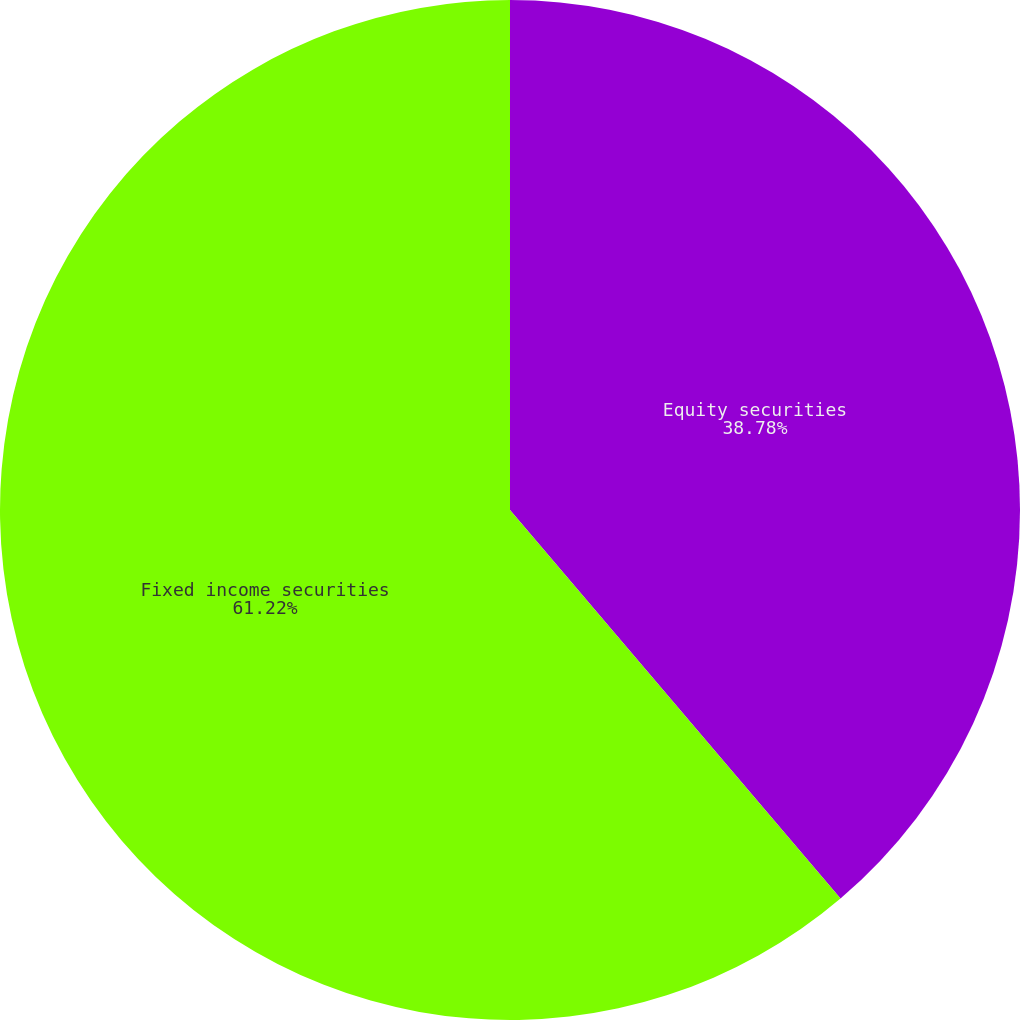<chart> <loc_0><loc_0><loc_500><loc_500><pie_chart><fcel>Equity securities<fcel>Fixed income securities<nl><fcel>38.78%<fcel>61.22%<nl></chart> 